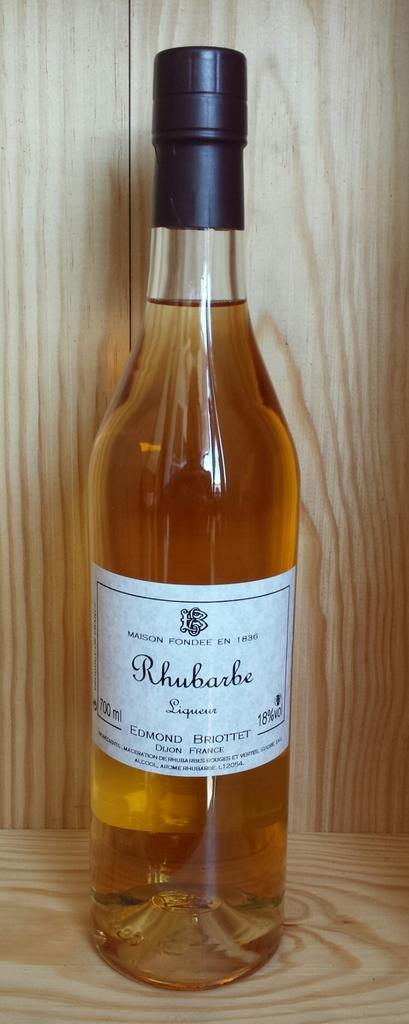<image>
Relay a brief, clear account of the picture shown. Rhubarb liqueur sits unopened on a wood surface. 